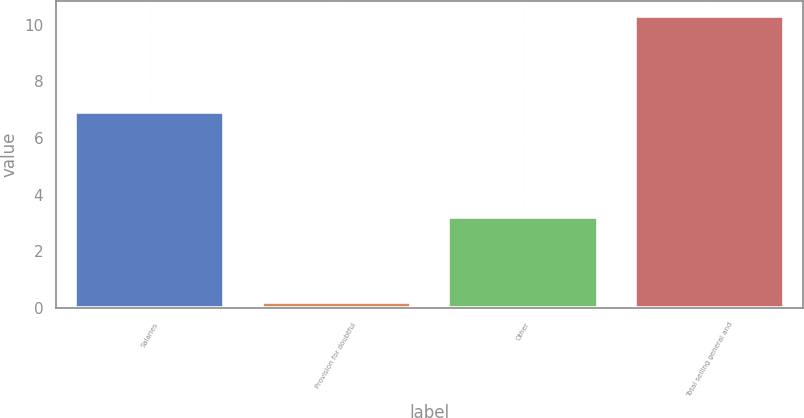Convert chart. <chart><loc_0><loc_0><loc_500><loc_500><bar_chart><fcel>Salaries<fcel>Provision for doubtful<fcel>Other<fcel>Total selling general and<nl><fcel>6.9<fcel>0.2<fcel>3.2<fcel>10.3<nl></chart> 